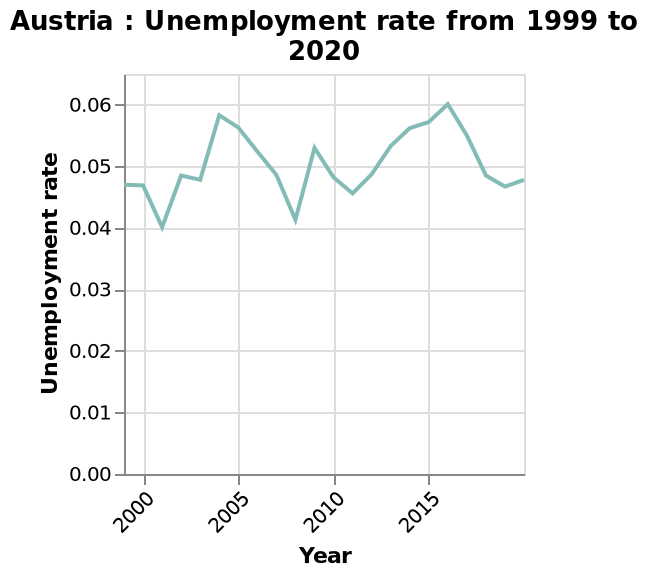<image>
What is the range of the unemployment rate in Austria between 1999 and 2020?  The range of the unemployment rate in Austria between 1999 and 2020 is between 0.04 and 0.06. Did the unemployment rate in Austria remain constant between 1999 and 2020?  No, the unemployment rate in Austria varied between a low of 0.04 and a high of 0.06 between 1999 and 2020. What is the range of the y-axis? The range of the y-axis is from 0.00 to 0.06. please summary the statistics and relations of the chart The unemployment rate in Austria has fluctuated from 4% to 6% over the period 2000 to 2020. Lowest was 4% around 2001 and again around 2008, with highest being almost 6% around 2004 and then 6% around 2016. After 2016 the rate fell every year to around 4.75% in 2019 but the latest figures show a very slight rise. 